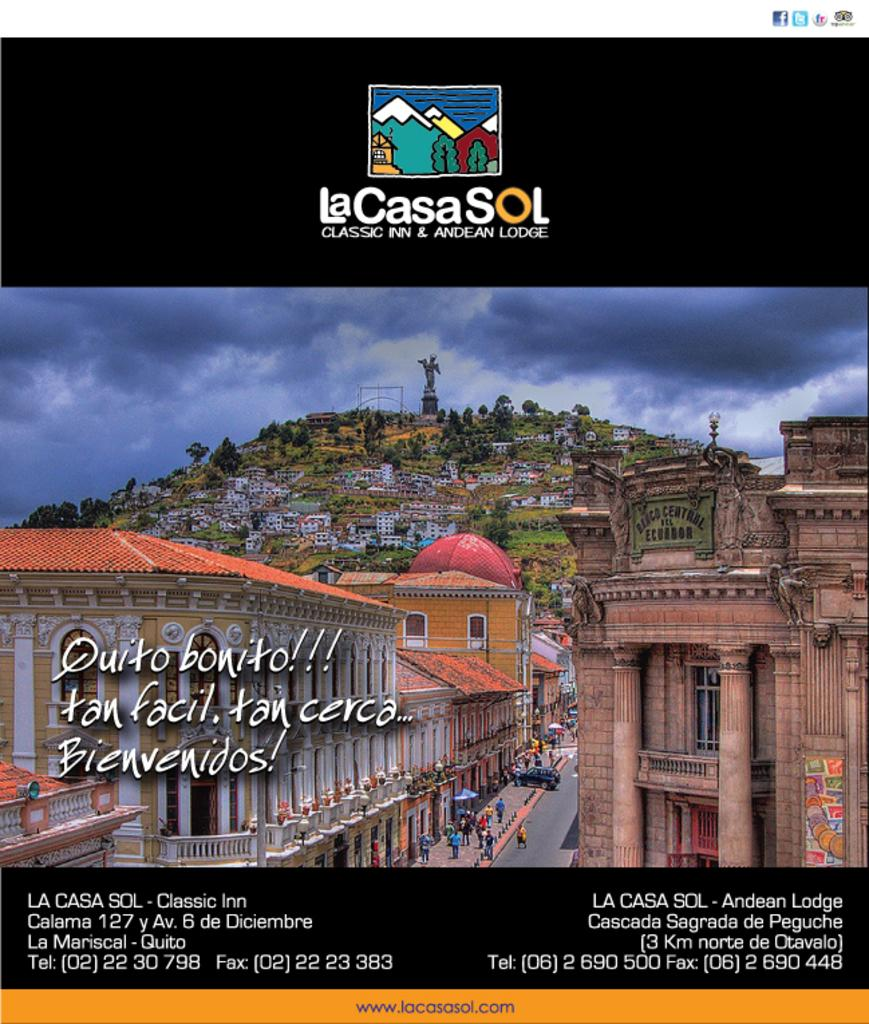What is the main setting of the image? There is a city in the image. What is a prominent feature within the city? There is a road in the city. What are the people in the image doing? People are walking on the road and on the mountain in the background. What can be seen in the distance behind the city? There is a mountain in the background with houses on it. What type of design can be seen on the ghost walking on the mountain? There is no ghost present in the image, so it is not possible to determine the design on any ghost. 